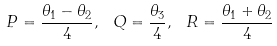<formula> <loc_0><loc_0><loc_500><loc_500>P = \frac { \theta _ { 1 } - \theta _ { 2 } } { 4 } , \ Q = \frac { \theta _ { 3 } } { 4 } , \ R = \frac { \theta _ { 1 } + \theta _ { 2 } } { 4 }</formula> 